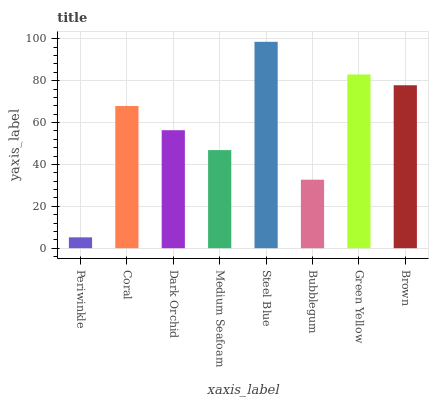Is Periwinkle the minimum?
Answer yes or no. Yes. Is Steel Blue the maximum?
Answer yes or no. Yes. Is Coral the minimum?
Answer yes or no. No. Is Coral the maximum?
Answer yes or no. No. Is Coral greater than Periwinkle?
Answer yes or no. Yes. Is Periwinkle less than Coral?
Answer yes or no. Yes. Is Periwinkle greater than Coral?
Answer yes or no. No. Is Coral less than Periwinkle?
Answer yes or no. No. Is Coral the high median?
Answer yes or no. Yes. Is Dark Orchid the low median?
Answer yes or no. Yes. Is Dark Orchid the high median?
Answer yes or no. No. Is Steel Blue the low median?
Answer yes or no. No. 